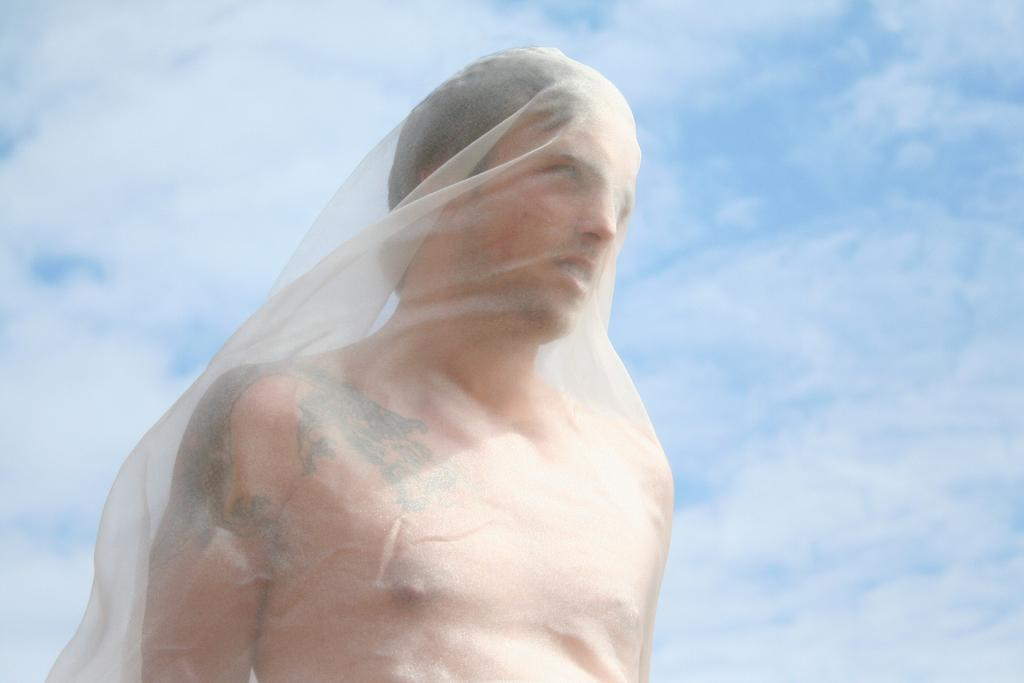Who is present in the image? There is a man in the image. What is the man wearing or holding in the image? The man has a cloth on him. What can be seen in the background of the image? There are clouds visible in the background of the image. What level of lead is present in the man's blood, as indicated by the image? The image does not provide any information about the man's blood lead levels. 